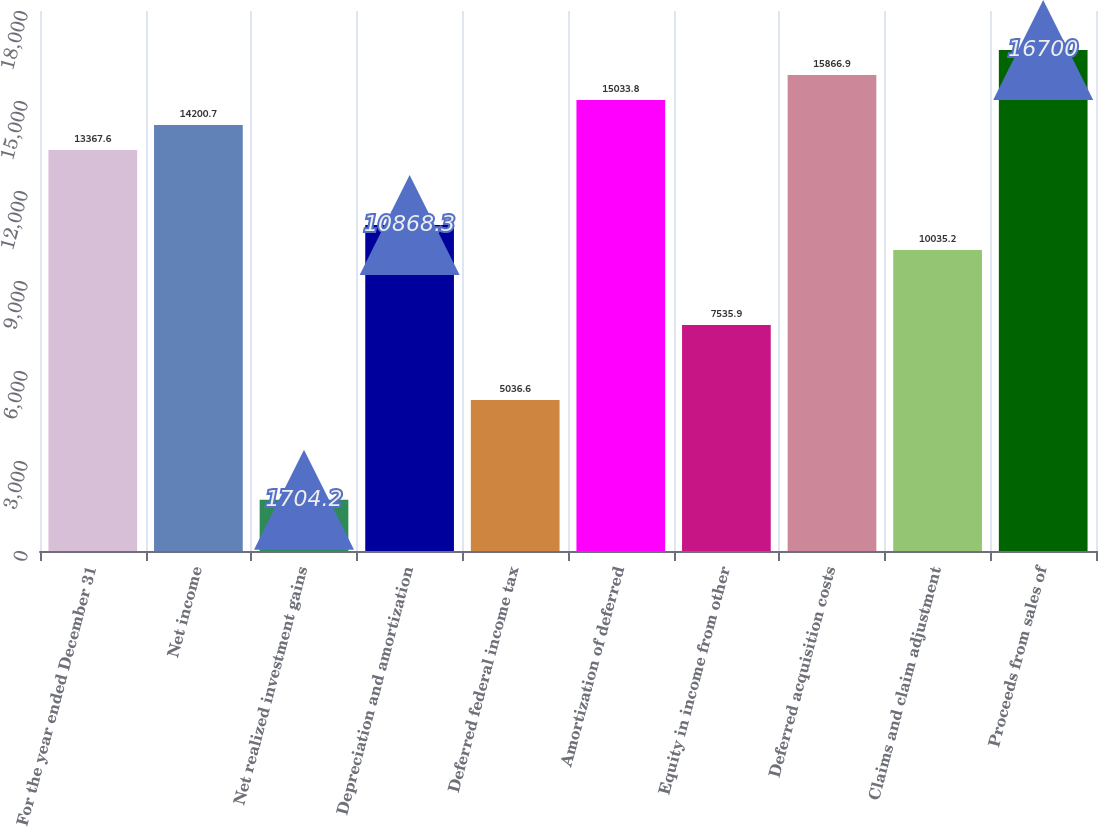Convert chart. <chart><loc_0><loc_0><loc_500><loc_500><bar_chart><fcel>For the year ended December 31<fcel>Net income<fcel>Net realized investment gains<fcel>Depreciation and amortization<fcel>Deferred federal income tax<fcel>Amortization of deferred<fcel>Equity in income from other<fcel>Deferred acquisition costs<fcel>Claims and claim adjustment<fcel>Proceeds from sales of<nl><fcel>13367.6<fcel>14200.7<fcel>1704.2<fcel>10868.3<fcel>5036.6<fcel>15033.8<fcel>7535.9<fcel>15866.9<fcel>10035.2<fcel>16700<nl></chart> 